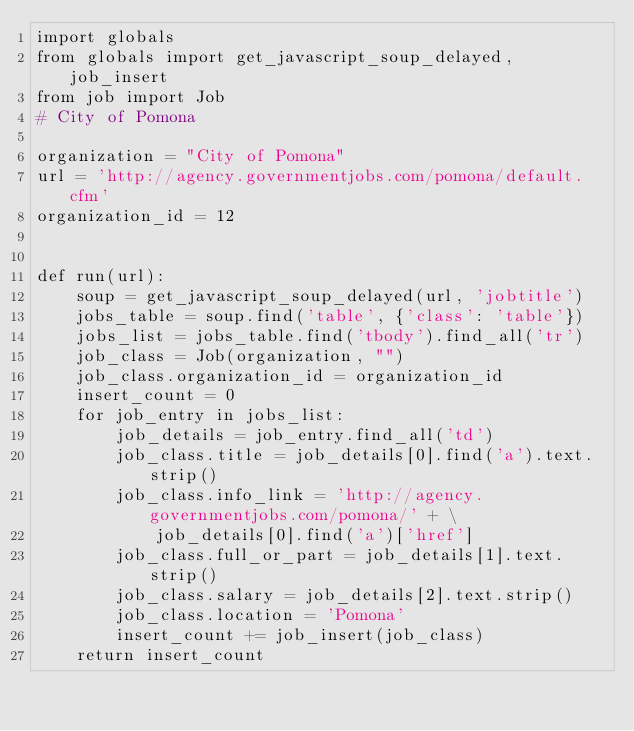<code> <loc_0><loc_0><loc_500><loc_500><_Python_>import globals
from globals import get_javascript_soup_delayed, job_insert
from job import Job
# City of Pomona

organization = "City of Pomona"
url = 'http://agency.governmentjobs.com/pomona/default.cfm'
organization_id = 12


def run(url):
    soup = get_javascript_soup_delayed(url, 'jobtitle')
    jobs_table = soup.find('table', {'class': 'table'})
    jobs_list = jobs_table.find('tbody').find_all('tr')
    job_class = Job(organization, "")
    job_class.organization_id = organization_id
    insert_count = 0
    for job_entry in jobs_list:
        job_details = job_entry.find_all('td')
        job_class.title = job_details[0].find('a').text.strip()
        job_class.info_link = 'http://agency.governmentjobs.com/pomona/' + \
            job_details[0].find('a')['href']
        job_class.full_or_part = job_details[1].text.strip()
        job_class.salary = job_details[2].text.strip()
        job_class.location = 'Pomona'
        insert_count += job_insert(job_class)
    return insert_count
</code> 